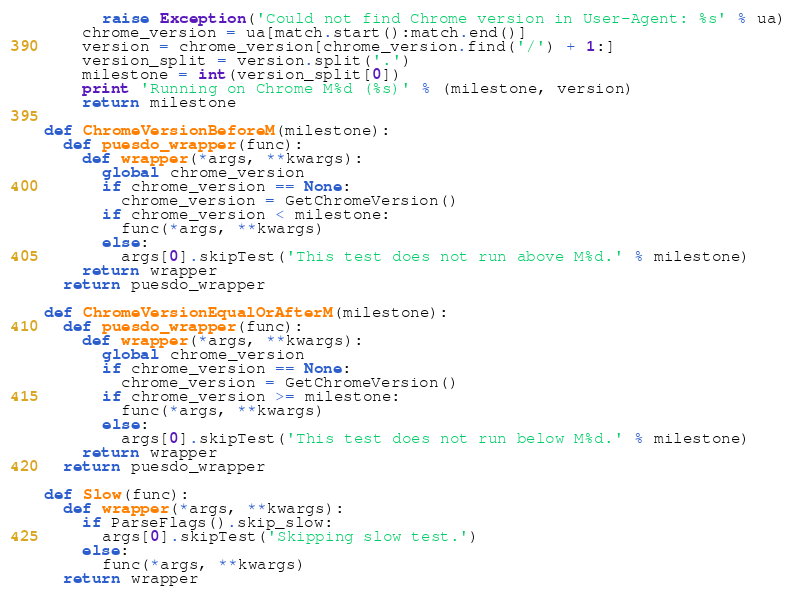<code> <loc_0><loc_0><loc_500><loc_500><_Python_>      raise Exception('Could not find Chrome version in User-Agent: %s' % ua)
    chrome_version = ua[match.start():match.end()]
    version = chrome_version[chrome_version.find('/') + 1:]
    version_split = version.split('.')
    milestone = int(version_split[0])
    print 'Running on Chrome M%d (%s)' % (milestone, version)
    return milestone

def ChromeVersionBeforeM(milestone):
  def puesdo_wrapper(func):
    def wrapper(*args, **kwargs):
      global chrome_version
      if chrome_version == None:
        chrome_version = GetChromeVersion()
      if chrome_version < milestone:
        func(*args, **kwargs)
      else:
        args[0].skipTest('This test does not run above M%d.' % milestone)
    return wrapper
  return puesdo_wrapper

def ChromeVersionEqualOrAfterM(milestone):
  def puesdo_wrapper(func):
    def wrapper(*args, **kwargs):
      global chrome_version
      if chrome_version == None:
        chrome_version = GetChromeVersion()
      if chrome_version >= milestone:
        func(*args, **kwargs)
      else:
        args[0].skipTest('This test does not run below M%d.' % milestone)
    return wrapper
  return puesdo_wrapper

def Slow(func):
  def wrapper(*args, **kwargs):
    if ParseFlags().skip_slow:
      args[0].skipTest('Skipping slow test.')
    else:
      func(*args, **kwargs)
  return wrapper
</code> 